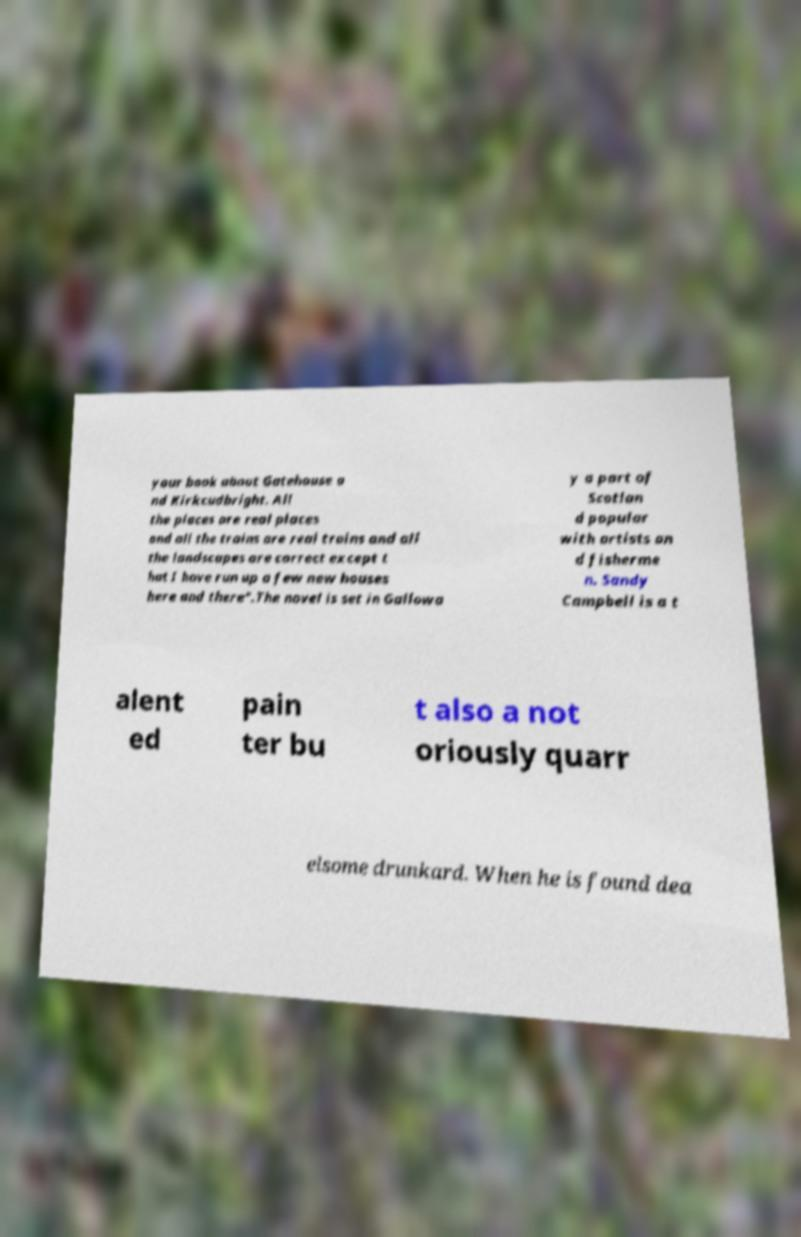There's text embedded in this image that I need extracted. Can you transcribe it verbatim? your book about Gatehouse a nd Kirkcudbright. All the places are real places and all the trains are real trains and all the landscapes are correct except t hat I have run up a few new houses here and there".The novel is set in Gallowa y a part of Scotlan d popular with artists an d fisherme n. Sandy Campbell is a t alent ed pain ter bu t also a not oriously quarr elsome drunkard. When he is found dea 